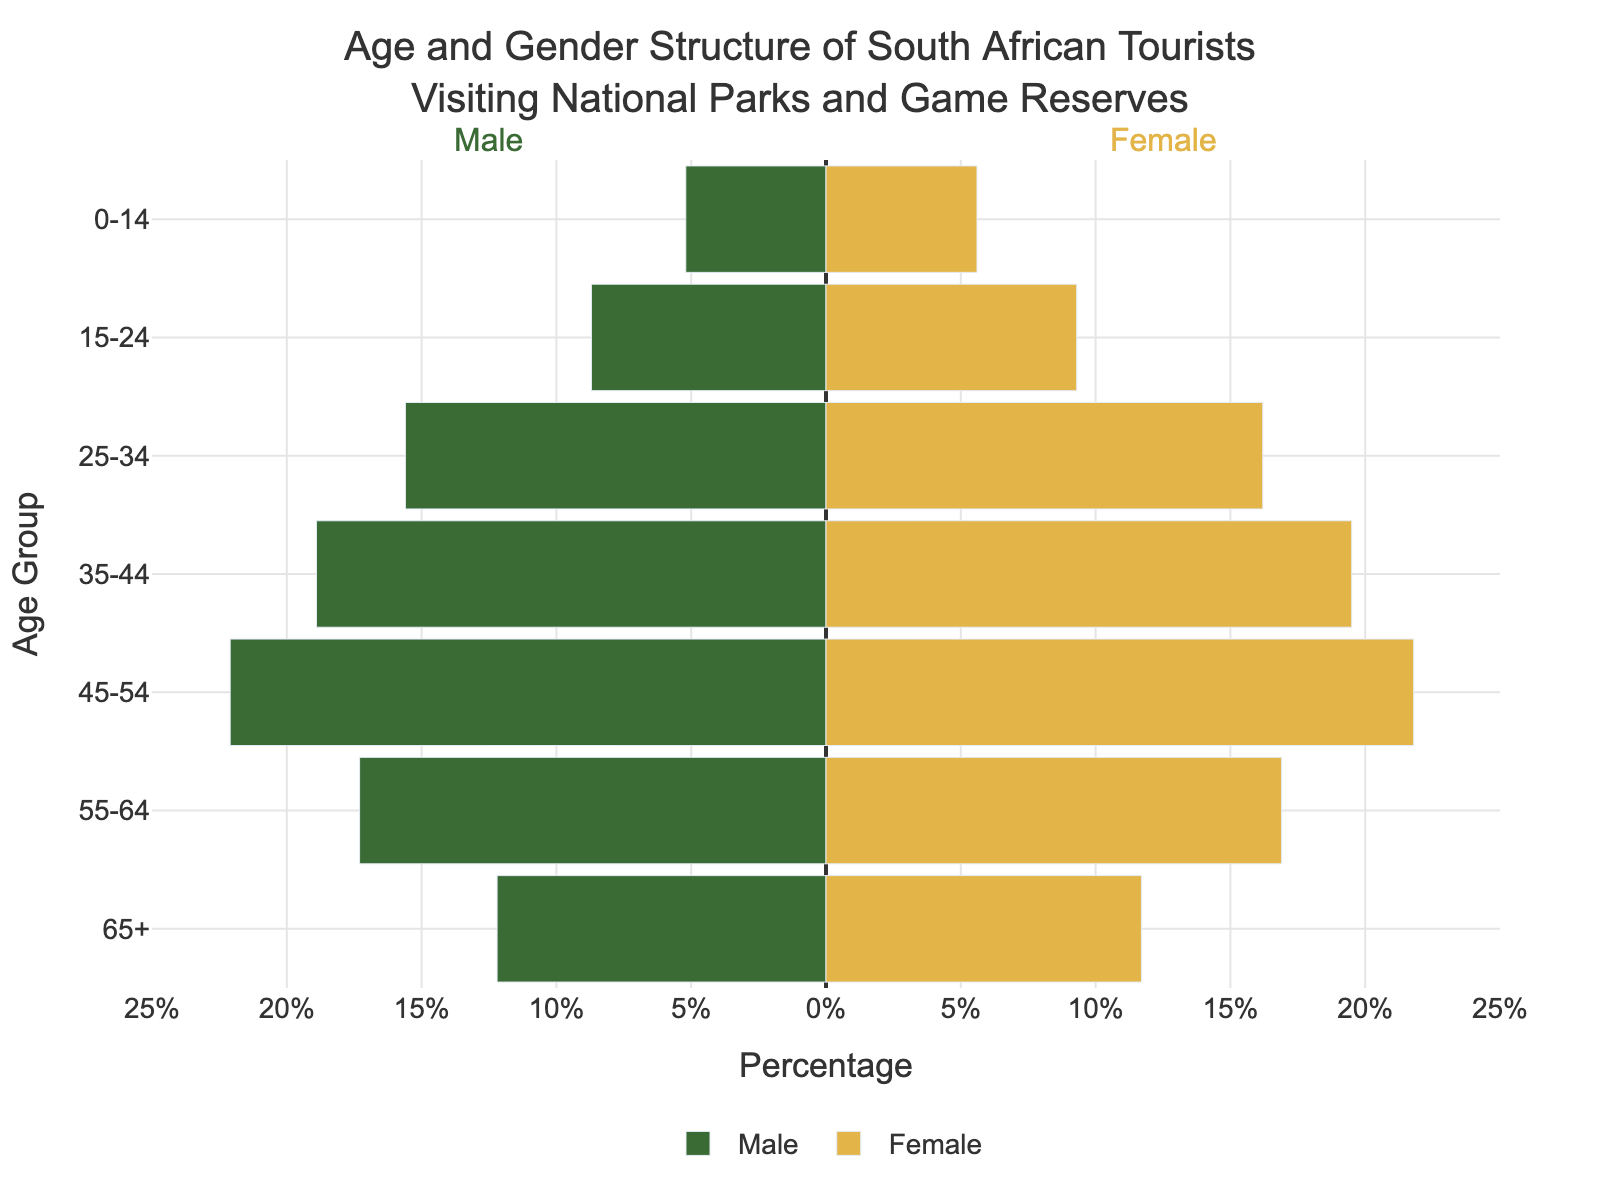What is the title of the figure? The title of the figure is located at the top and it describes the main topic of the plot. In this case, the title is "Age and Gender Structure of South African Tourists Visiting National Parks and Game Reserves."
Answer: Age and Gender Structure of South African Tourists Visiting National Parks and Game Reserves Which age group has the highest percentage of female tourists? According to the data, the 35-44 age group has the highest percentage of female tourists. You can identify this by looking at the longest bar on the right side (female) of the pyramid.
Answer: 35-44 What is the percentage difference between male and female tourists in the 15-24 age group? In the 15-24 age group, the percentage of female tourists is 9.3% and male tourists is 8.7%. The difference is calculated by subtracting the lower value from the higher value: 9.3% - 8.7% = 0.6%.
Answer: 0.6% Which gender has a higher percentage of tourists in the 45-54 age group? The figure shows bars for both genders in the 45-54 age group. The bar for males is slightly longer at 22.1% compared to females at 21.8%. Therefore, males have a higher percentage.
Answer: Male What is the total percentage of tourists aged 55 years and older (65+ group) for both genders combined? The percentage for males aged 65+ is 12.2% and for females, it is 11.7%. To find the total percentage, you add these two values together: 12.2% + 11.7% = 23.9%.
Answer: 23.9% How does the percentage of male tourists in the 25-34 age group compare to that in the 35-44 age group? In the 25-34 age group, the percentage of male tourists is 15.6%. In the 35-44 age group, it's 18.9%. By comparing the two values, we can see that the percentage in the 35-44 age group is higher.
Answer: Higher in 35-44 Which age group has the smallest gender difference, and what is the main reason for your answer? The smallest gender difference can be found by comparing the difference between male and female percentages in each age group. The 45-54 age group has the smallest difference with males at 22.1% and females at 21.8%, giving a difference of 0.3%.
Answer: 45-54 What percentage of the total tourist population does the 0-14 age group represent for both genders combined? For the 0-14 age group, the percentage is 5.2% for males and 5.6% for females. Adding these yields 10.8%.
Answer: 10.8% Which gender and age group combination has the highest percentage of tourists? By examining the bars, the age group 45-54 for males has the highest percentage at 22.1%.
Answer: Males 45-54 